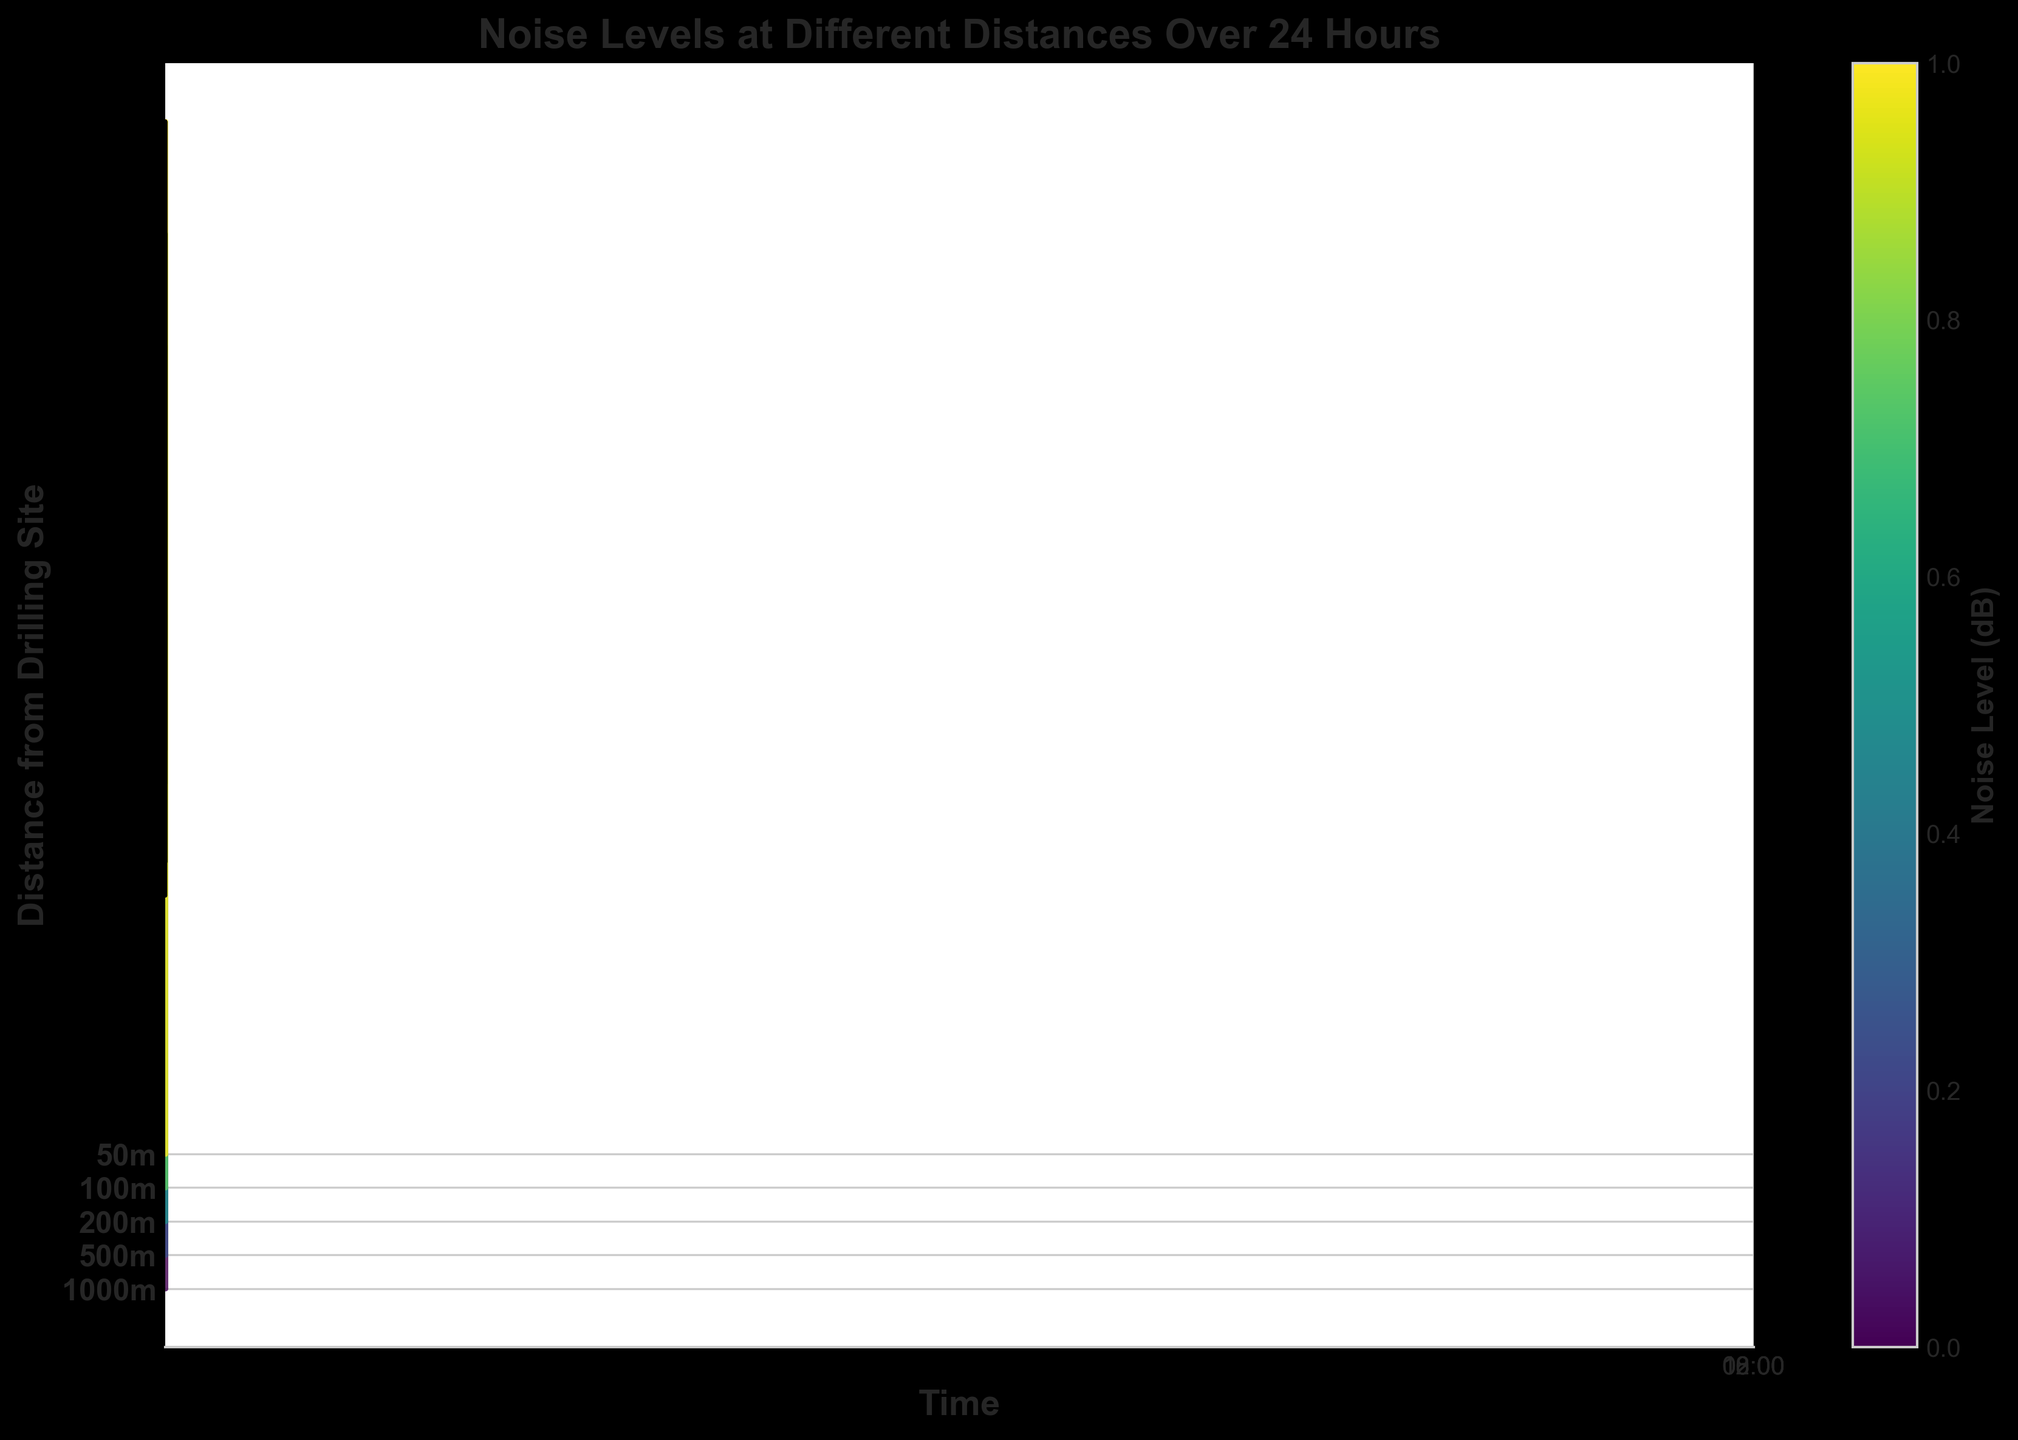What is the title of the figure? The title of the figure is written at the top and serves as a description of what the plot represents. The title in this case is "Noise Levels at Different Distances Over 24 Hours"
Answer: Noise Levels at Different Distances Over 24 Hours What is the noise level at 50m at 12:00? Look for the ridgeline corresponding to 50m and locate the noise level at the 12:00 time point. The plot shows that the noise level is at its peak for this distance and time.
Answer: 92 dB At what time does the noise level reach its maximum at 1000m? Check the ridgeline corresponding to 1000m and identify the time point where the noise level is highest. The visual data shows that the highest point is at 12:00.
Answer: 12:00 Which distance has the lowest noise level at any time, and what is its value? Observe all the ridgelines to find the minimum noise level across all distances and times. The 1000m distance has the lowest noise level at 00:00.
Answer: 35 dB at 1000m at 00:00 How does the noise level at 500m at 18:00 compare to the noise level at 50m at the same time? Look at the ridgelines for 500m and 50m at 18:00 and compare their heights. The 50m ridgeline is higher.
Answer: 62 dB at 500m vs. 85 dB at 50m What is the change in noise levels from 12:00 to 18:00 at 200m? Identify the noise levels at 200m at both 12:00 and 18:00 and calculate the difference. The levels are 78 dB at 12:00 and 72 dB at 18:00.
Answer: 78 dB - 72 dB = 6 dB decrease Which distance shows the most significant fluctuation in noise levels over 24 hours? Look at the range of noise levels for each distance from the smallest to the largest and compare their extents. The 50m and 100m distances show the highest fluctuations.
Answer: 50m What pattern do you observe with noise levels as the distance from the drilling site increases? Examine the ridgelines from 50m to 1000m and note how the noise levels change across different times. As the distance increases, the noise levels generally decrease.
Answer: Noise levels decrease with distance At what time point is the noise level equal to 78 dB at 50m? Find the ridgeline for 50m and locate where the noise level intersects with 78 dB. This occurs at 06:00 and closely around between 50 m and 200 m.
Answer: 06:00 What does the color of the ridgelines represent in the plot? The color gradient in the ridgelines indicates different noise levels, with the color bar legend showing the corresponding dB values. Darker colors represent higher noise levels.
Answer: Noise level (dB) 